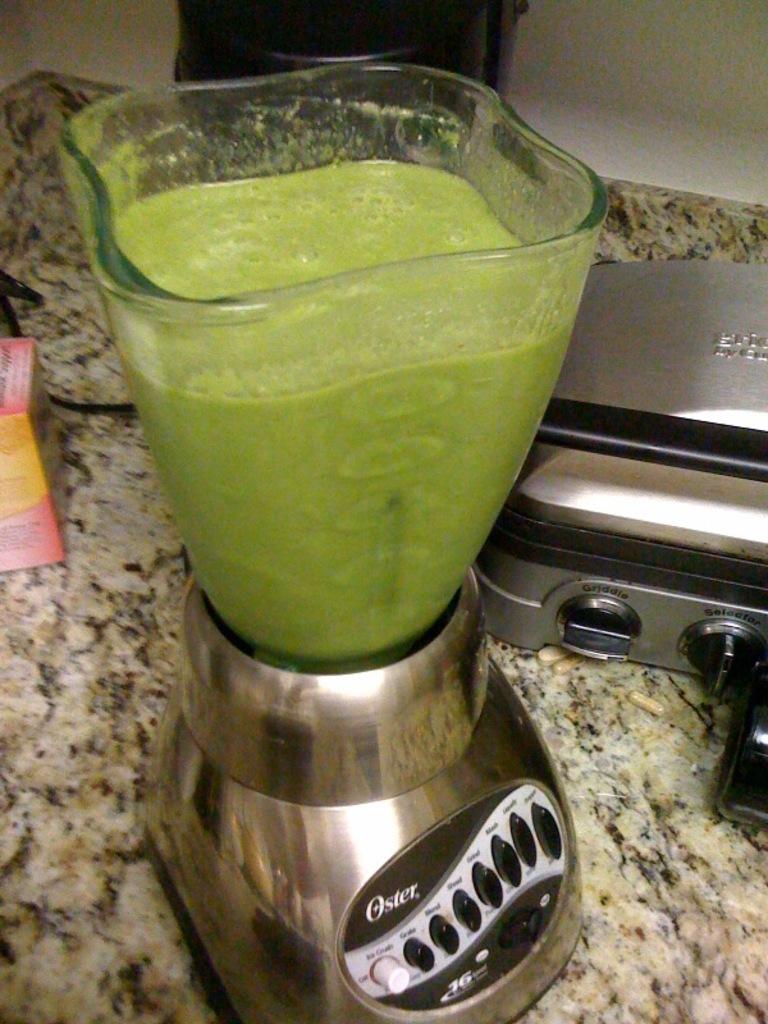Who made the blender?
Your response must be concise. Oster. What company logo is on the blender?
Your answer should be compact. Oster. 